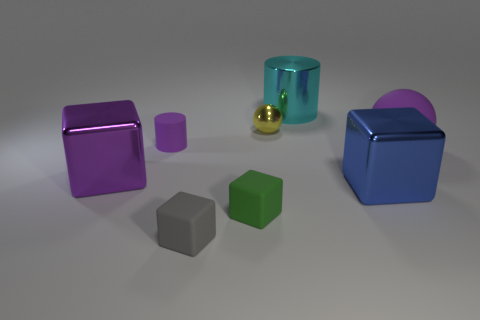Can you describe the setting in which these objects are placed? The objects are arranged on a smooth, neutral gray surface that appears to stretch endlessly, with a slightly darker background suggesting an open, minimalist space that could be found in a gallery or a design studio. 